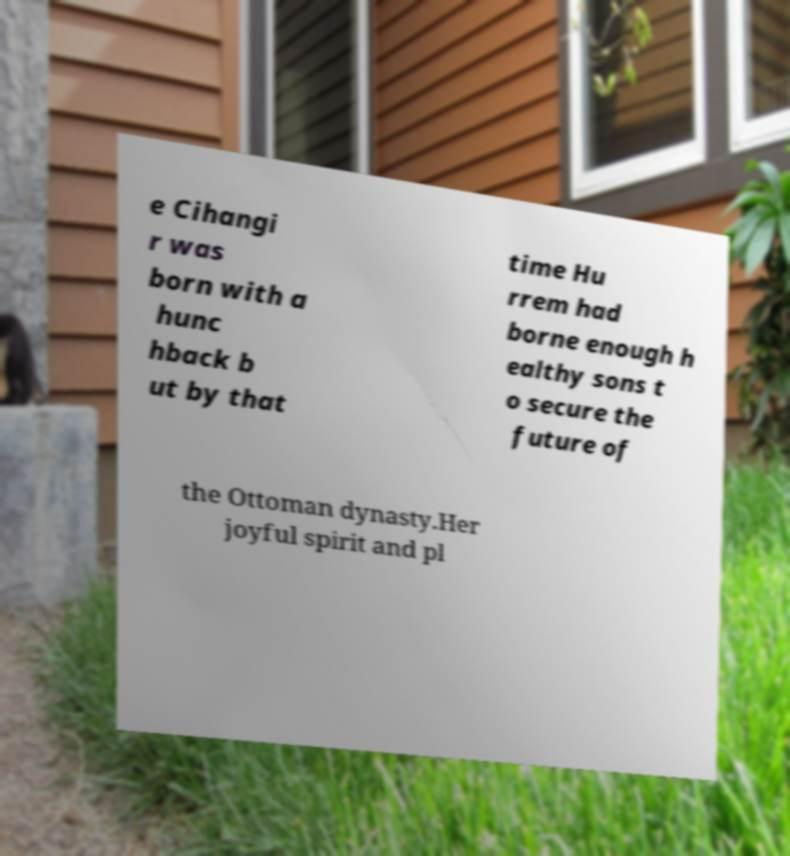For documentation purposes, I need the text within this image transcribed. Could you provide that? e Cihangi r was born with a hunc hback b ut by that time Hu rrem had borne enough h ealthy sons t o secure the future of the Ottoman dynasty.Her joyful spirit and pl 